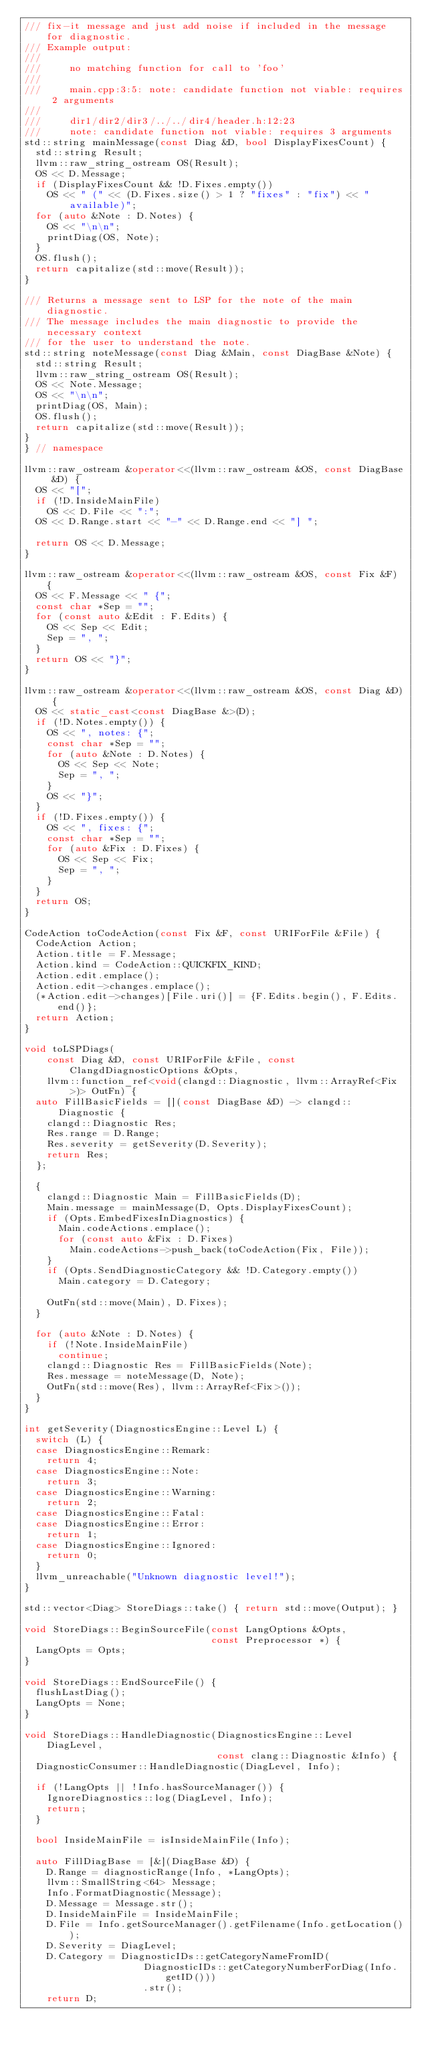Convert code to text. <code><loc_0><loc_0><loc_500><loc_500><_C++_>/// fix-it message and just add noise if included in the message for diagnostic.
/// Example output:
///
///     no matching function for call to 'foo'
///
///     main.cpp:3:5: note: candidate function not viable: requires 2 arguments
///
///     dir1/dir2/dir3/../../dir4/header.h:12:23
///     note: candidate function not viable: requires 3 arguments
std::string mainMessage(const Diag &D, bool DisplayFixesCount) {
  std::string Result;
  llvm::raw_string_ostream OS(Result);
  OS << D.Message;
  if (DisplayFixesCount && !D.Fixes.empty())
    OS << " (" << (D.Fixes.size() > 1 ? "fixes" : "fix") << " available)";
  for (auto &Note : D.Notes) {
    OS << "\n\n";
    printDiag(OS, Note);
  }
  OS.flush();
  return capitalize(std::move(Result));
}

/// Returns a message sent to LSP for the note of the main diagnostic.
/// The message includes the main diagnostic to provide the necessary context
/// for the user to understand the note.
std::string noteMessage(const Diag &Main, const DiagBase &Note) {
  std::string Result;
  llvm::raw_string_ostream OS(Result);
  OS << Note.Message;
  OS << "\n\n";
  printDiag(OS, Main);
  OS.flush();
  return capitalize(std::move(Result));
}
} // namespace

llvm::raw_ostream &operator<<(llvm::raw_ostream &OS, const DiagBase &D) {
  OS << "[";
  if (!D.InsideMainFile)
    OS << D.File << ":";
  OS << D.Range.start << "-" << D.Range.end << "] ";

  return OS << D.Message;
}

llvm::raw_ostream &operator<<(llvm::raw_ostream &OS, const Fix &F) {
  OS << F.Message << " {";
  const char *Sep = "";
  for (const auto &Edit : F.Edits) {
    OS << Sep << Edit;
    Sep = ", ";
  }
  return OS << "}";
}

llvm::raw_ostream &operator<<(llvm::raw_ostream &OS, const Diag &D) {
  OS << static_cast<const DiagBase &>(D);
  if (!D.Notes.empty()) {
    OS << ", notes: {";
    const char *Sep = "";
    for (auto &Note : D.Notes) {
      OS << Sep << Note;
      Sep = ", ";
    }
    OS << "}";
  }
  if (!D.Fixes.empty()) {
    OS << ", fixes: {";
    const char *Sep = "";
    for (auto &Fix : D.Fixes) {
      OS << Sep << Fix;
      Sep = ", ";
    }
  }
  return OS;
}

CodeAction toCodeAction(const Fix &F, const URIForFile &File) {
  CodeAction Action;
  Action.title = F.Message;
  Action.kind = CodeAction::QUICKFIX_KIND;
  Action.edit.emplace();
  Action.edit->changes.emplace();
  (*Action.edit->changes)[File.uri()] = {F.Edits.begin(), F.Edits.end()};
  return Action;
}

void toLSPDiags(
    const Diag &D, const URIForFile &File, const ClangdDiagnosticOptions &Opts,
    llvm::function_ref<void(clangd::Diagnostic, llvm::ArrayRef<Fix>)> OutFn) {
  auto FillBasicFields = [](const DiagBase &D) -> clangd::Diagnostic {
    clangd::Diagnostic Res;
    Res.range = D.Range;
    Res.severity = getSeverity(D.Severity);
    return Res;
  };

  {
    clangd::Diagnostic Main = FillBasicFields(D);
    Main.message = mainMessage(D, Opts.DisplayFixesCount);
    if (Opts.EmbedFixesInDiagnostics) {
      Main.codeActions.emplace();
      for (const auto &Fix : D.Fixes)
        Main.codeActions->push_back(toCodeAction(Fix, File));
    }
    if (Opts.SendDiagnosticCategory && !D.Category.empty())
      Main.category = D.Category;

    OutFn(std::move(Main), D.Fixes);
  }

  for (auto &Note : D.Notes) {
    if (!Note.InsideMainFile)
      continue;
    clangd::Diagnostic Res = FillBasicFields(Note);
    Res.message = noteMessage(D, Note);
    OutFn(std::move(Res), llvm::ArrayRef<Fix>());
  }
}

int getSeverity(DiagnosticsEngine::Level L) {
  switch (L) {
  case DiagnosticsEngine::Remark:
    return 4;
  case DiagnosticsEngine::Note:
    return 3;
  case DiagnosticsEngine::Warning:
    return 2;
  case DiagnosticsEngine::Fatal:
  case DiagnosticsEngine::Error:
    return 1;
  case DiagnosticsEngine::Ignored:
    return 0;
  }
  llvm_unreachable("Unknown diagnostic level!");
}

std::vector<Diag> StoreDiags::take() { return std::move(Output); }

void StoreDiags::BeginSourceFile(const LangOptions &Opts,
                                 const Preprocessor *) {
  LangOpts = Opts;
}

void StoreDiags::EndSourceFile() {
  flushLastDiag();
  LangOpts = None;
}

void StoreDiags::HandleDiagnostic(DiagnosticsEngine::Level DiagLevel,
                                  const clang::Diagnostic &Info) {
  DiagnosticConsumer::HandleDiagnostic(DiagLevel, Info);

  if (!LangOpts || !Info.hasSourceManager()) {
    IgnoreDiagnostics::log(DiagLevel, Info);
    return;
  }

  bool InsideMainFile = isInsideMainFile(Info);

  auto FillDiagBase = [&](DiagBase &D) {
    D.Range = diagnosticRange(Info, *LangOpts);
    llvm::SmallString<64> Message;
    Info.FormatDiagnostic(Message);
    D.Message = Message.str();
    D.InsideMainFile = InsideMainFile;
    D.File = Info.getSourceManager().getFilename(Info.getLocation());
    D.Severity = DiagLevel;
    D.Category = DiagnosticIDs::getCategoryNameFromID(
                     DiagnosticIDs::getCategoryNumberForDiag(Info.getID()))
                     .str();
    return D;</code> 